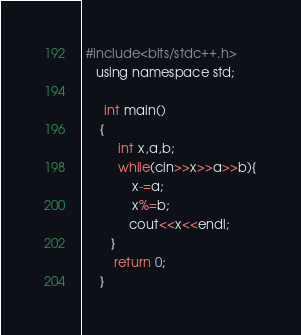Convert code to text. <code><loc_0><loc_0><loc_500><loc_500><_Awk_> #include<bits/stdc++.h>
    using namespace std;
       
      int main()
     {
          int x,a,b;
          while(cin>>x>>a>>b){
              x-=a;
              x%=b;
             cout<<x<<endl;
        }
         return 0;
     }
</code> 